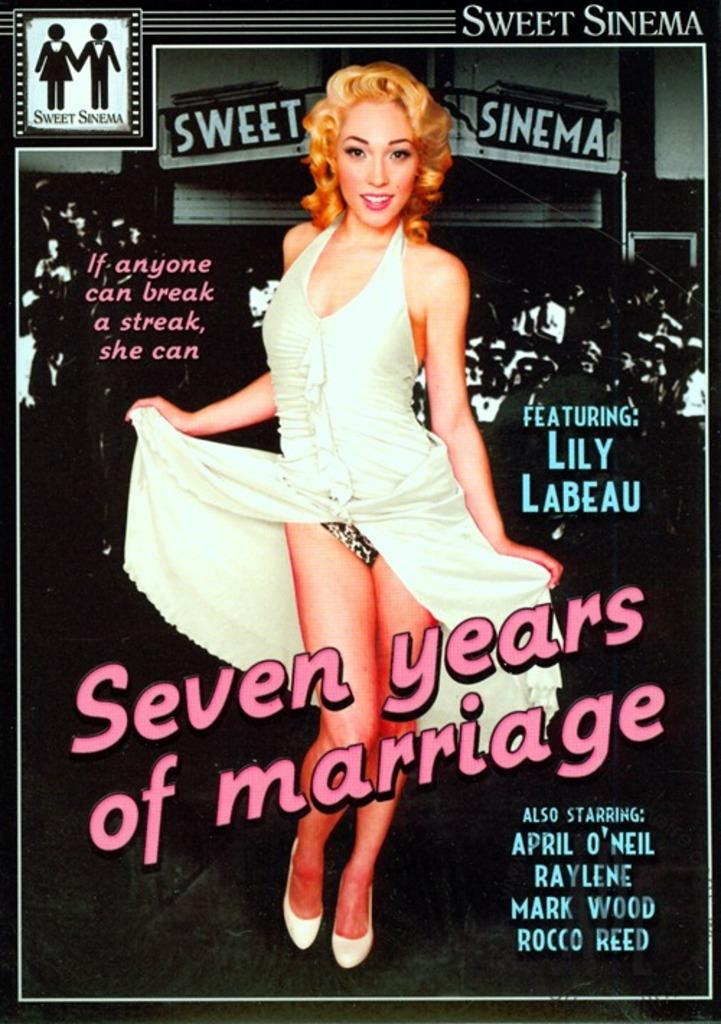What is depicted on the poster in the image? There is a poster of a woman in the image. What else can be seen on the poster besides the woman? There is text on the poster. Where is the logo located on the poster? The logo is in the top left corner of the poster. What type of invention is shown on the roof of the building in the image? There is no building or invention present in the image; it only features a poster with a woman, text, and a logo. 